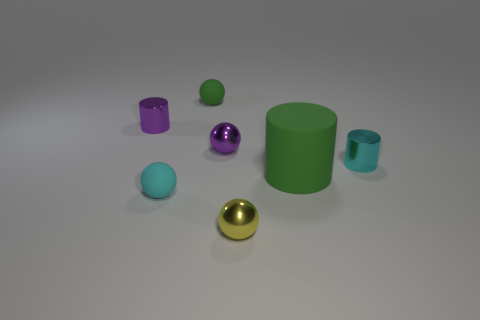Can you tell me about the colors and shapes present in the image? Certainly! The image presents a variety of geometric shapes, including cylinders, spheres, and cubes. As for colors, we have objects in green, cyan, purple, and gold. A large green cylinder and a smaller cyan-colored one are noticeable, accompanied by spheres which include a shiny purple and a matte green. A gold sphere adds a touch of metallic luster. Each object’s color and texture interact with the light, creating an aesthetic composition of hues and reflections. 